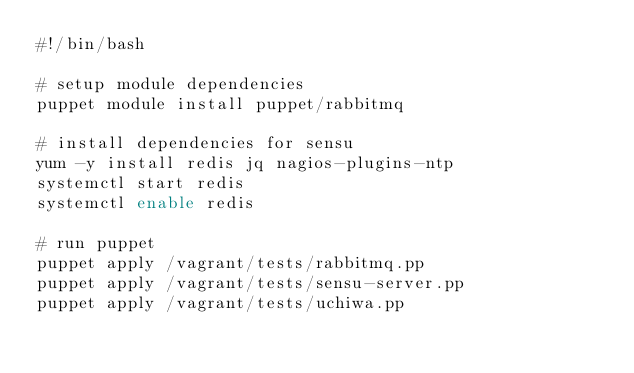Convert code to text. <code><loc_0><loc_0><loc_500><loc_500><_Bash_>#!/bin/bash

# setup module dependencies
puppet module install puppet/rabbitmq

# install dependencies for sensu
yum -y install redis jq nagios-plugins-ntp
systemctl start redis
systemctl enable redis

# run puppet
puppet apply /vagrant/tests/rabbitmq.pp
puppet apply /vagrant/tests/sensu-server.pp
puppet apply /vagrant/tests/uchiwa.pp
</code> 